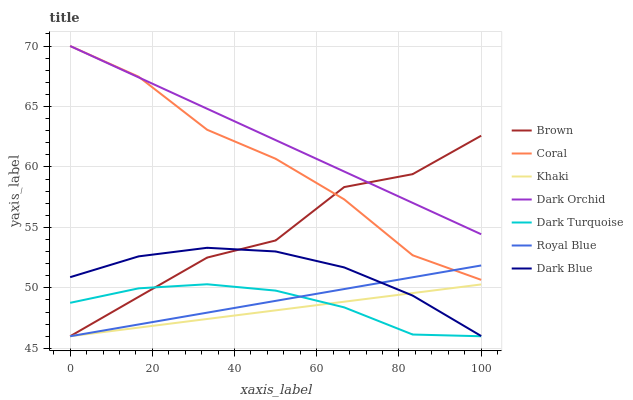Does Khaki have the minimum area under the curve?
Answer yes or no. Yes. Does Dark Orchid have the maximum area under the curve?
Answer yes or no. Yes. Does Dark Blue have the minimum area under the curve?
Answer yes or no. No. Does Dark Blue have the maximum area under the curve?
Answer yes or no. No. Is Khaki the smoothest?
Answer yes or no. Yes. Is Brown the roughest?
Answer yes or no. Yes. Is Dark Blue the smoothest?
Answer yes or no. No. Is Dark Blue the roughest?
Answer yes or no. No. Does Brown have the lowest value?
Answer yes or no. Yes. Does Dark Blue have the lowest value?
Answer yes or no. No. Does Dark Orchid have the highest value?
Answer yes or no. Yes. Does Dark Blue have the highest value?
Answer yes or no. No. Is Khaki less than Dark Orchid?
Answer yes or no. Yes. Is Coral greater than Dark Blue?
Answer yes or no. Yes. Does Royal Blue intersect Dark Blue?
Answer yes or no. Yes. Is Royal Blue less than Dark Blue?
Answer yes or no. No. Is Royal Blue greater than Dark Blue?
Answer yes or no. No. Does Khaki intersect Dark Orchid?
Answer yes or no. No. 